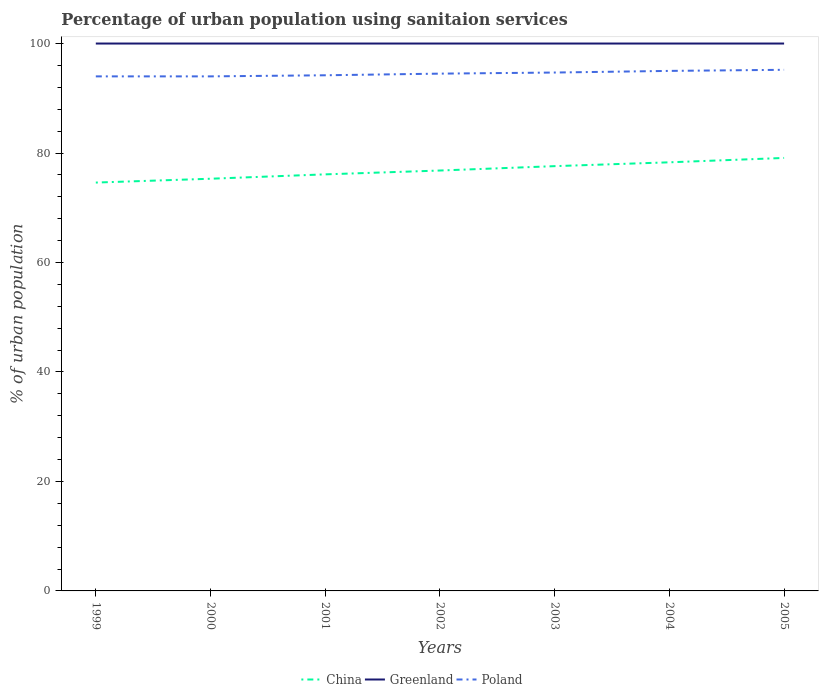How many different coloured lines are there?
Make the answer very short. 3. Does the line corresponding to China intersect with the line corresponding to Poland?
Keep it short and to the point. No. Is the number of lines equal to the number of legend labels?
Give a very brief answer. Yes. Across all years, what is the maximum percentage of urban population using sanitaion services in China?
Give a very brief answer. 74.6. What is the total percentage of urban population using sanitaion services in China in the graph?
Make the answer very short. -0.8. What is the difference between the highest and the second highest percentage of urban population using sanitaion services in Poland?
Make the answer very short. 1.2. How many lines are there?
Give a very brief answer. 3. What is the difference between two consecutive major ticks on the Y-axis?
Offer a terse response. 20. Are the values on the major ticks of Y-axis written in scientific E-notation?
Keep it short and to the point. No. Where does the legend appear in the graph?
Provide a succinct answer. Bottom center. How are the legend labels stacked?
Keep it short and to the point. Horizontal. What is the title of the graph?
Your answer should be compact. Percentage of urban population using sanitaion services. What is the label or title of the X-axis?
Your answer should be very brief. Years. What is the label or title of the Y-axis?
Provide a short and direct response. % of urban population. What is the % of urban population in China in 1999?
Your answer should be compact. 74.6. What is the % of urban population in Poland in 1999?
Your answer should be compact. 94. What is the % of urban population of China in 2000?
Your response must be concise. 75.3. What is the % of urban population in Poland in 2000?
Your response must be concise. 94. What is the % of urban population in China in 2001?
Provide a short and direct response. 76.1. What is the % of urban population of Poland in 2001?
Make the answer very short. 94.2. What is the % of urban population in China in 2002?
Offer a terse response. 76.8. What is the % of urban population in Greenland in 2002?
Your answer should be very brief. 100. What is the % of urban population in Poland in 2002?
Provide a succinct answer. 94.5. What is the % of urban population in China in 2003?
Ensure brevity in your answer.  77.6. What is the % of urban population of Poland in 2003?
Give a very brief answer. 94.7. What is the % of urban population in China in 2004?
Provide a succinct answer. 78.3. What is the % of urban population in China in 2005?
Provide a short and direct response. 79.1. What is the % of urban population of Poland in 2005?
Keep it short and to the point. 95.2. Across all years, what is the maximum % of urban population in China?
Your answer should be compact. 79.1. Across all years, what is the maximum % of urban population of Poland?
Give a very brief answer. 95.2. Across all years, what is the minimum % of urban population in China?
Offer a very short reply. 74.6. Across all years, what is the minimum % of urban population in Greenland?
Your answer should be very brief. 100. Across all years, what is the minimum % of urban population in Poland?
Ensure brevity in your answer.  94. What is the total % of urban population in China in the graph?
Provide a short and direct response. 537.8. What is the total % of urban population in Greenland in the graph?
Keep it short and to the point. 700. What is the total % of urban population of Poland in the graph?
Your response must be concise. 661.6. What is the difference between the % of urban population in China in 1999 and that in 2000?
Provide a succinct answer. -0.7. What is the difference between the % of urban population in Poland in 1999 and that in 2000?
Ensure brevity in your answer.  0. What is the difference between the % of urban population of China in 1999 and that in 2001?
Your response must be concise. -1.5. What is the difference between the % of urban population of Greenland in 1999 and that in 2001?
Your response must be concise. 0. What is the difference between the % of urban population of Poland in 1999 and that in 2002?
Make the answer very short. -0.5. What is the difference between the % of urban population in Greenland in 1999 and that in 2004?
Your answer should be compact. 0. What is the difference between the % of urban population of Greenland in 1999 and that in 2005?
Your answer should be compact. 0. What is the difference between the % of urban population of Poland in 1999 and that in 2005?
Offer a very short reply. -1.2. What is the difference between the % of urban population in China in 2000 and that in 2001?
Offer a very short reply. -0.8. What is the difference between the % of urban population of Poland in 2000 and that in 2001?
Ensure brevity in your answer.  -0.2. What is the difference between the % of urban population of China in 2000 and that in 2004?
Your answer should be very brief. -3. What is the difference between the % of urban population of China in 2000 and that in 2005?
Give a very brief answer. -3.8. What is the difference between the % of urban population in Greenland in 2000 and that in 2005?
Provide a succinct answer. 0. What is the difference between the % of urban population in Poland in 2000 and that in 2005?
Provide a short and direct response. -1.2. What is the difference between the % of urban population in China in 2001 and that in 2002?
Make the answer very short. -0.7. What is the difference between the % of urban population of Greenland in 2001 and that in 2002?
Offer a very short reply. 0. What is the difference between the % of urban population of China in 2001 and that in 2003?
Keep it short and to the point. -1.5. What is the difference between the % of urban population in Poland in 2001 and that in 2003?
Ensure brevity in your answer.  -0.5. What is the difference between the % of urban population of Greenland in 2001 and that in 2004?
Offer a very short reply. 0. What is the difference between the % of urban population in China in 2001 and that in 2005?
Your response must be concise. -3. What is the difference between the % of urban population of Greenland in 2001 and that in 2005?
Offer a very short reply. 0. What is the difference between the % of urban population of Poland in 2001 and that in 2005?
Your answer should be very brief. -1. What is the difference between the % of urban population in China in 2002 and that in 2003?
Give a very brief answer. -0.8. What is the difference between the % of urban population of China in 2002 and that in 2004?
Give a very brief answer. -1.5. What is the difference between the % of urban population of Greenland in 2002 and that in 2004?
Keep it short and to the point. 0. What is the difference between the % of urban population in Poland in 2002 and that in 2004?
Provide a short and direct response. -0.5. What is the difference between the % of urban population in Greenland in 2002 and that in 2005?
Provide a short and direct response. 0. What is the difference between the % of urban population in Greenland in 2003 and that in 2004?
Your response must be concise. 0. What is the difference between the % of urban population in Poland in 2003 and that in 2004?
Make the answer very short. -0.3. What is the difference between the % of urban population of China in 2003 and that in 2005?
Provide a succinct answer. -1.5. What is the difference between the % of urban population of Greenland in 2003 and that in 2005?
Offer a terse response. 0. What is the difference between the % of urban population in Poland in 2003 and that in 2005?
Provide a short and direct response. -0.5. What is the difference between the % of urban population in China in 2004 and that in 2005?
Your response must be concise. -0.8. What is the difference between the % of urban population of Greenland in 2004 and that in 2005?
Provide a short and direct response. 0. What is the difference between the % of urban population in Poland in 2004 and that in 2005?
Make the answer very short. -0.2. What is the difference between the % of urban population of China in 1999 and the % of urban population of Greenland in 2000?
Provide a succinct answer. -25.4. What is the difference between the % of urban population of China in 1999 and the % of urban population of Poland in 2000?
Offer a very short reply. -19.4. What is the difference between the % of urban population in China in 1999 and the % of urban population in Greenland in 2001?
Provide a short and direct response. -25.4. What is the difference between the % of urban population of China in 1999 and the % of urban population of Poland in 2001?
Keep it short and to the point. -19.6. What is the difference between the % of urban population in Greenland in 1999 and the % of urban population in Poland in 2001?
Keep it short and to the point. 5.8. What is the difference between the % of urban population of China in 1999 and the % of urban population of Greenland in 2002?
Your answer should be very brief. -25.4. What is the difference between the % of urban population in China in 1999 and the % of urban population in Poland in 2002?
Your response must be concise. -19.9. What is the difference between the % of urban population in Greenland in 1999 and the % of urban population in Poland in 2002?
Your answer should be compact. 5.5. What is the difference between the % of urban population in China in 1999 and the % of urban population in Greenland in 2003?
Give a very brief answer. -25.4. What is the difference between the % of urban population in China in 1999 and the % of urban population in Poland in 2003?
Your response must be concise. -20.1. What is the difference between the % of urban population of China in 1999 and the % of urban population of Greenland in 2004?
Ensure brevity in your answer.  -25.4. What is the difference between the % of urban population in China in 1999 and the % of urban population in Poland in 2004?
Your answer should be very brief. -20.4. What is the difference between the % of urban population in China in 1999 and the % of urban population in Greenland in 2005?
Your answer should be very brief. -25.4. What is the difference between the % of urban population in China in 1999 and the % of urban population in Poland in 2005?
Offer a very short reply. -20.6. What is the difference between the % of urban population of China in 2000 and the % of urban population of Greenland in 2001?
Make the answer very short. -24.7. What is the difference between the % of urban population of China in 2000 and the % of urban population of Poland in 2001?
Your answer should be compact. -18.9. What is the difference between the % of urban population of Greenland in 2000 and the % of urban population of Poland in 2001?
Give a very brief answer. 5.8. What is the difference between the % of urban population in China in 2000 and the % of urban population in Greenland in 2002?
Your answer should be very brief. -24.7. What is the difference between the % of urban population in China in 2000 and the % of urban population in Poland in 2002?
Offer a terse response. -19.2. What is the difference between the % of urban population of Greenland in 2000 and the % of urban population of Poland in 2002?
Give a very brief answer. 5.5. What is the difference between the % of urban population in China in 2000 and the % of urban population in Greenland in 2003?
Provide a short and direct response. -24.7. What is the difference between the % of urban population of China in 2000 and the % of urban population of Poland in 2003?
Keep it short and to the point. -19.4. What is the difference between the % of urban population of Greenland in 2000 and the % of urban population of Poland in 2003?
Your answer should be compact. 5.3. What is the difference between the % of urban population of China in 2000 and the % of urban population of Greenland in 2004?
Offer a very short reply. -24.7. What is the difference between the % of urban population of China in 2000 and the % of urban population of Poland in 2004?
Give a very brief answer. -19.7. What is the difference between the % of urban population in China in 2000 and the % of urban population in Greenland in 2005?
Ensure brevity in your answer.  -24.7. What is the difference between the % of urban population in China in 2000 and the % of urban population in Poland in 2005?
Your answer should be very brief. -19.9. What is the difference between the % of urban population in Greenland in 2000 and the % of urban population in Poland in 2005?
Offer a terse response. 4.8. What is the difference between the % of urban population of China in 2001 and the % of urban population of Greenland in 2002?
Your answer should be very brief. -23.9. What is the difference between the % of urban population of China in 2001 and the % of urban population of Poland in 2002?
Ensure brevity in your answer.  -18.4. What is the difference between the % of urban population in Greenland in 2001 and the % of urban population in Poland in 2002?
Offer a terse response. 5.5. What is the difference between the % of urban population of China in 2001 and the % of urban population of Greenland in 2003?
Your response must be concise. -23.9. What is the difference between the % of urban population in China in 2001 and the % of urban population in Poland in 2003?
Provide a succinct answer. -18.6. What is the difference between the % of urban population of China in 2001 and the % of urban population of Greenland in 2004?
Make the answer very short. -23.9. What is the difference between the % of urban population of China in 2001 and the % of urban population of Poland in 2004?
Keep it short and to the point. -18.9. What is the difference between the % of urban population of China in 2001 and the % of urban population of Greenland in 2005?
Ensure brevity in your answer.  -23.9. What is the difference between the % of urban population of China in 2001 and the % of urban population of Poland in 2005?
Keep it short and to the point. -19.1. What is the difference between the % of urban population of Greenland in 2001 and the % of urban population of Poland in 2005?
Provide a succinct answer. 4.8. What is the difference between the % of urban population of China in 2002 and the % of urban population of Greenland in 2003?
Ensure brevity in your answer.  -23.2. What is the difference between the % of urban population of China in 2002 and the % of urban population of Poland in 2003?
Provide a short and direct response. -17.9. What is the difference between the % of urban population of China in 2002 and the % of urban population of Greenland in 2004?
Offer a very short reply. -23.2. What is the difference between the % of urban population in China in 2002 and the % of urban population in Poland in 2004?
Your answer should be very brief. -18.2. What is the difference between the % of urban population of China in 2002 and the % of urban population of Greenland in 2005?
Your answer should be compact. -23.2. What is the difference between the % of urban population of China in 2002 and the % of urban population of Poland in 2005?
Offer a very short reply. -18.4. What is the difference between the % of urban population in China in 2003 and the % of urban population in Greenland in 2004?
Give a very brief answer. -22.4. What is the difference between the % of urban population in China in 2003 and the % of urban population in Poland in 2004?
Ensure brevity in your answer.  -17.4. What is the difference between the % of urban population in Greenland in 2003 and the % of urban population in Poland in 2004?
Provide a short and direct response. 5. What is the difference between the % of urban population in China in 2003 and the % of urban population in Greenland in 2005?
Keep it short and to the point. -22.4. What is the difference between the % of urban population of China in 2003 and the % of urban population of Poland in 2005?
Give a very brief answer. -17.6. What is the difference between the % of urban population in Greenland in 2003 and the % of urban population in Poland in 2005?
Offer a terse response. 4.8. What is the difference between the % of urban population of China in 2004 and the % of urban population of Greenland in 2005?
Provide a short and direct response. -21.7. What is the difference between the % of urban population in China in 2004 and the % of urban population in Poland in 2005?
Provide a short and direct response. -16.9. What is the difference between the % of urban population of Greenland in 2004 and the % of urban population of Poland in 2005?
Provide a succinct answer. 4.8. What is the average % of urban population in China per year?
Your response must be concise. 76.83. What is the average % of urban population of Greenland per year?
Your answer should be very brief. 100. What is the average % of urban population in Poland per year?
Offer a very short reply. 94.51. In the year 1999, what is the difference between the % of urban population of China and % of urban population of Greenland?
Your response must be concise. -25.4. In the year 1999, what is the difference between the % of urban population in China and % of urban population in Poland?
Offer a very short reply. -19.4. In the year 1999, what is the difference between the % of urban population in Greenland and % of urban population in Poland?
Ensure brevity in your answer.  6. In the year 2000, what is the difference between the % of urban population in China and % of urban population in Greenland?
Provide a succinct answer. -24.7. In the year 2000, what is the difference between the % of urban population of China and % of urban population of Poland?
Your answer should be very brief. -18.7. In the year 2001, what is the difference between the % of urban population of China and % of urban population of Greenland?
Make the answer very short. -23.9. In the year 2001, what is the difference between the % of urban population of China and % of urban population of Poland?
Keep it short and to the point. -18.1. In the year 2002, what is the difference between the % of urban population in China and % of urban population in Greenland?
Your response must be concise. -23.2. In the year 2002, what is the difference between the % of urban population of China and % of urban population of Poland?
Offer a very short reply. -17.7. In the year 2002, what is the difference between the % of urban population in Greenland and % of urban population in Poland?
Your response must be concise. 5.5. In the year 2003, what is the difference between the % of urban population of China and % of urban population of Greenland?
Your response must be concise. -22.4. In the year 2003, what is the difference between the % of urban population in China and % of urban population in Poland?
Offer a very short reply. -17.1. In the year 2004, what is the difference between the % of urban population in China and % of urban population in Greenland?
Give a very brief answer. -21.7. In the year 2004, what is the difference between the % of urban population in China and % of urban population in Poland?
Ensure brevity in your answer.  -16.7. In the year 2004, what is the difference between the % of urban population of Greenland and % of urban population of Poland?
Your answer should be very brief. 5. In the year 2005, what is the difference between the % of urban population in China and % of urban population in Greenland?
Your answer should be very brief. -20.9. In the year 2005, what is the difference between the % of urban population of China and % of urban population of Poland?
Ensure brevity in your answer.  -16.1. What is the ratio of the % of urban population of China in 1999 to that in 2000?
Your response must be concise. 0.99. What is the ratio of the % of urban population in Greenland in 1999 to that in 2000?
Ensure brevity in your answer.  1. What is the ratio of the % of urban population in Poland in 1999 to that in 2000?
Your answer should be very brief. 1. What is the ratio of the % of urban population in China in 1999 to that in 2001?
Make the answer very short. 0.98. What is the ratio of the % of urban population of Greenland in 1999 to that in 2001?
Offer a terse response. 1. What is the ratio of the % of urban population in Poland in 1999 to that in 2001?
Offer a terse response. 1. What is the ratio of the % of urban population of China in 1999 to that in 2002?
Offer a very short reply. 0.97. What is the ratio of the % of urban population in Greenland in 1999 to that in 2002?
Provide a succinct answer. 1. What is the ratio of the % of urban population in China in 1999 to that in 2003?
Ensure brevity in your answer.  0.96. What is the ratio of the % of urban population in Greenland in 1999 to that in 2003?
Provide a short and direct response. 1. What is the ratio of the % of urban population of China in 1999 to that in 2004?
Make the answer very short. 0.95. What is the ratio of the % of urban population in China in 1999 to that in 2005?
Your response must be concise. 0.94. What is the ratio of the % of urban population in Poland in 1999 to that in 2005?
Your answer should be compact. 0.99. What is the ratio of the % of urban population in China in 2000 to that in 2002?
Give a very brief answer. 0.98. What is the ratio of the % of urban population in Greenland in 2000 to that in 2002?
Provide a short and direct response. 1. What is the ratio of the % of urban population of China in 2000 to that in 2003?
Offer a very short reply. 0.97. What is the ratio of the % of urban population of Poland in 2000 to that in 2003?
Your response must be concise. 0.99. What is the ratio of the % of urban population in China in 2000 to that in 2004?
Your answer should be compact. 0.96. What is the ratio of the % of urban population of Greenland in 2000 to that in 2004?
Keep it short and to the point. 1. What is the ratio of the % of urban population of Poland in 2000 to that in 2004?
Ensure brevity in your answer.  0.99. What is the ratio of the % of urban population of China in 2000 to that in 2005?
Provide a succinct answer. 0.95. What is the ratio of the % of urban population in Greenland in 2000 to that in 2005?
Make the answer very short. 1. What is the ratio of the % of urban population of Poland in 2000 to that in 2005?
Your answer should be compact. 0.99. What is the ratio of the % of urban population of China in 2001 to that in 2002?
Make the answer very short. 0.99. What is the ratio of the % of urban population in Greenland in 2001 to that in 2002?
Offer a terse response. 1. What is the ratio of the % of urban population of China in 2001 to that in 2003?
Give a very brief answer. 0.98. What is the ratio of the % of urban population in Greenland in 2001 to that in 2003?
Offer a terse response. 1. What is the ratio of the % of urban population in Poland in 2001 to that in 2003?
Provide a succinct answer. 0.99. What is the ratio of the % of urban population in China in 2001 to that in 2004?
Give a very brief answer. 0.97. What is the ratio of the % of urban population in China in 2001 to that in 2005?
Your response must be concise. 0.96. What is the ratio of the % of urban population in China in 2002 to that in 2003?
Your answer should be very brief. 0.99. What is the ratio of the % of urban population of Greenland in 2002 to that in 2003?
Offer a terse response. 1. What is the ratio of the % of urban population in China in 2002 to that in 2004?
Keep it short and to the point. 0.98. What is the ratio of the % of urban population of Poland in 2002 to that in 2004?
Give a very brief answer. 0.99. What is the ratio of the % of urban population of China in 2002 to that in 2005?
Your response must be concise. 0.97. What is the ratio of the % of urban population of Greenland in 2003 to that in 2005?
Give a very brief answer. 1. What is the ratio of the % of urban population in Greenland in 2004 to that in 2005?
Keep it short and to the point. 1. What is the difference between the highest and the second highest % of urban population in Greenland?
Give a very brief answer. 0. What is the difference between the highest and the second highest % of urban population in Poland?
Your answer should be compact. 0.2. What is the difference between the highest and the lowest % of urban population of China?
Your answer should be compact. 4.5. 